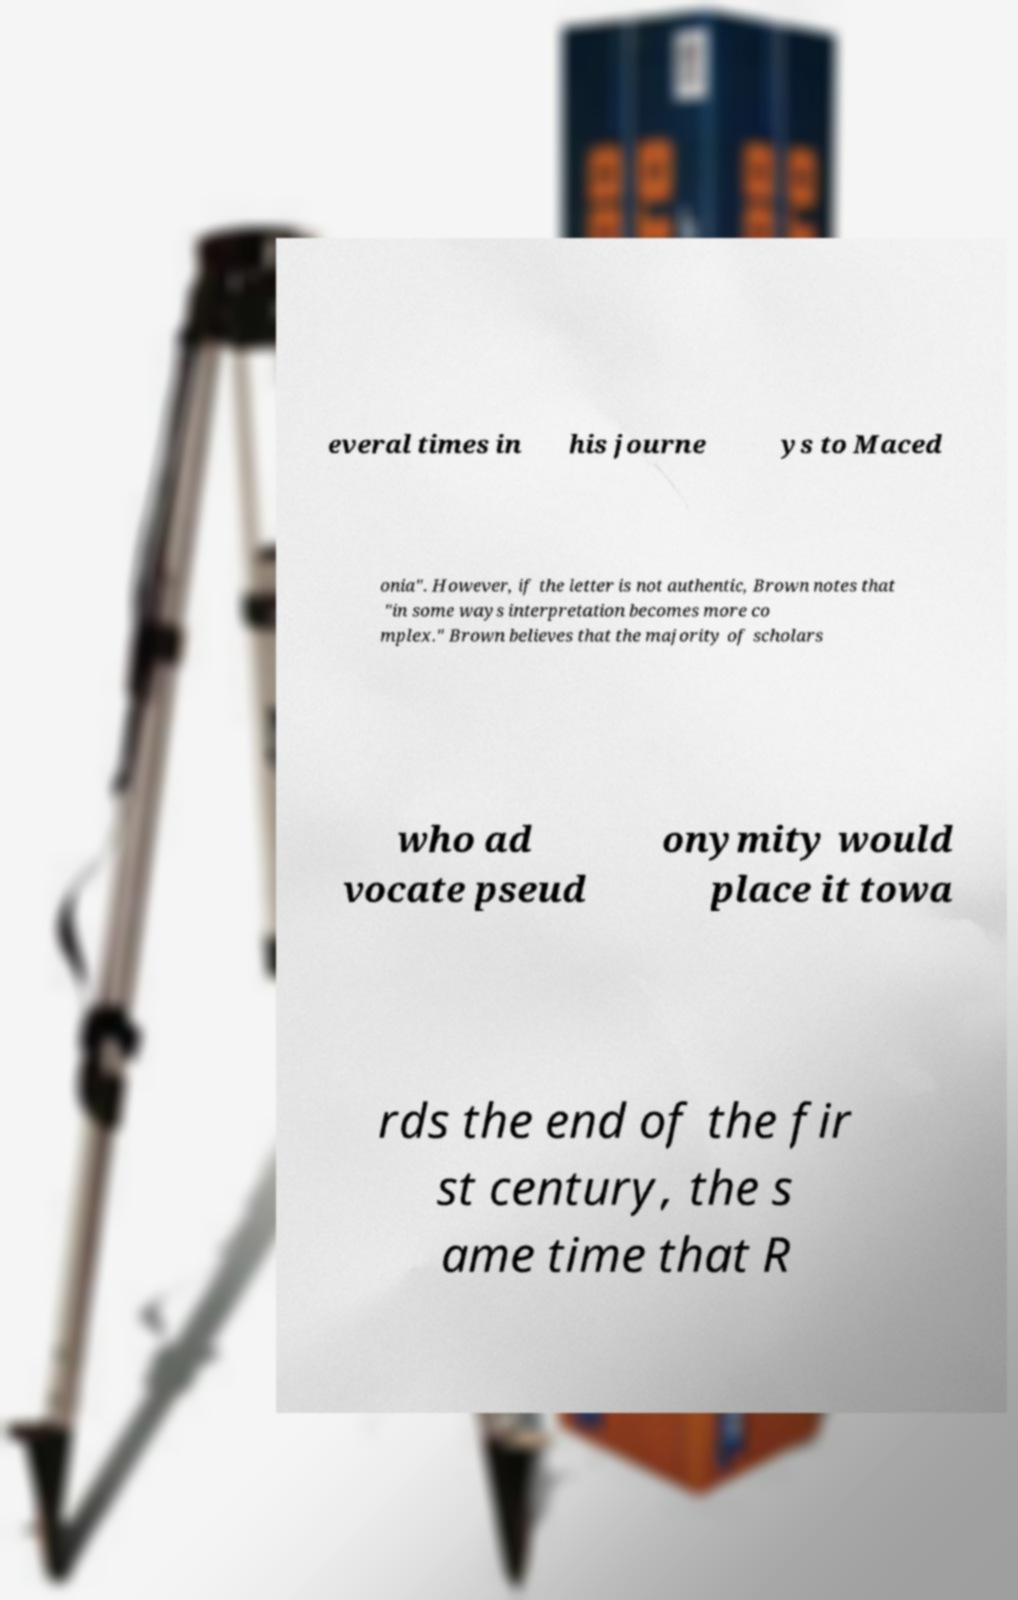Please read and relay the text visible in this image. What does it say? everal times in his journe ys to Maced onia". However, if the letter is not authentic, Brown notes that "in some ways interpretation becomes more co mplex." Brown believes that the majority of scholars who ad vocate pseud onymity would place it towa rds the end of the fir st century, the s ame time that R 